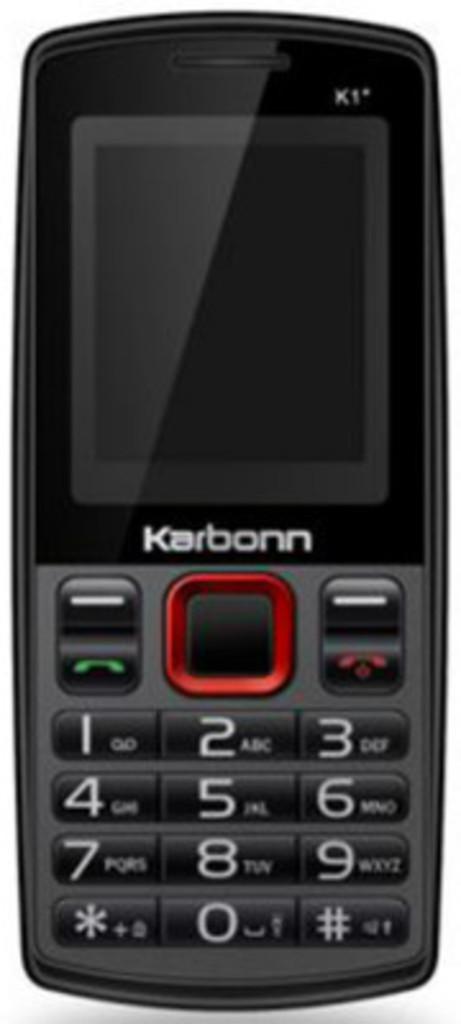Who is the manufacturer of the cell phone?
Give a very brief answer. Karbonn. What is the bottom number on the phone?
Your answer should be compact. 0. 